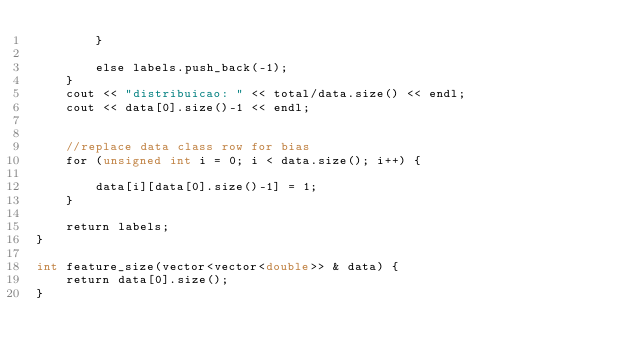<code> <loc_0><loc_0><loc_500><loc_500><_Cuda_>        }

        else labels.push_back(-1);
    }
    cout << "distribuicao: " << total/data.size() << endl;
    cout << data[0].size()-1 << endl;


    //replace data class row for bias
    for (unsigned int i = 0; i < data.size(); i++) {
        
        data[i][data[0].size()-1] = 1;
    }

    return labels;
}

int feature_size(vector<vector<double>> & data) {
    return data[0].size();
}</code> 